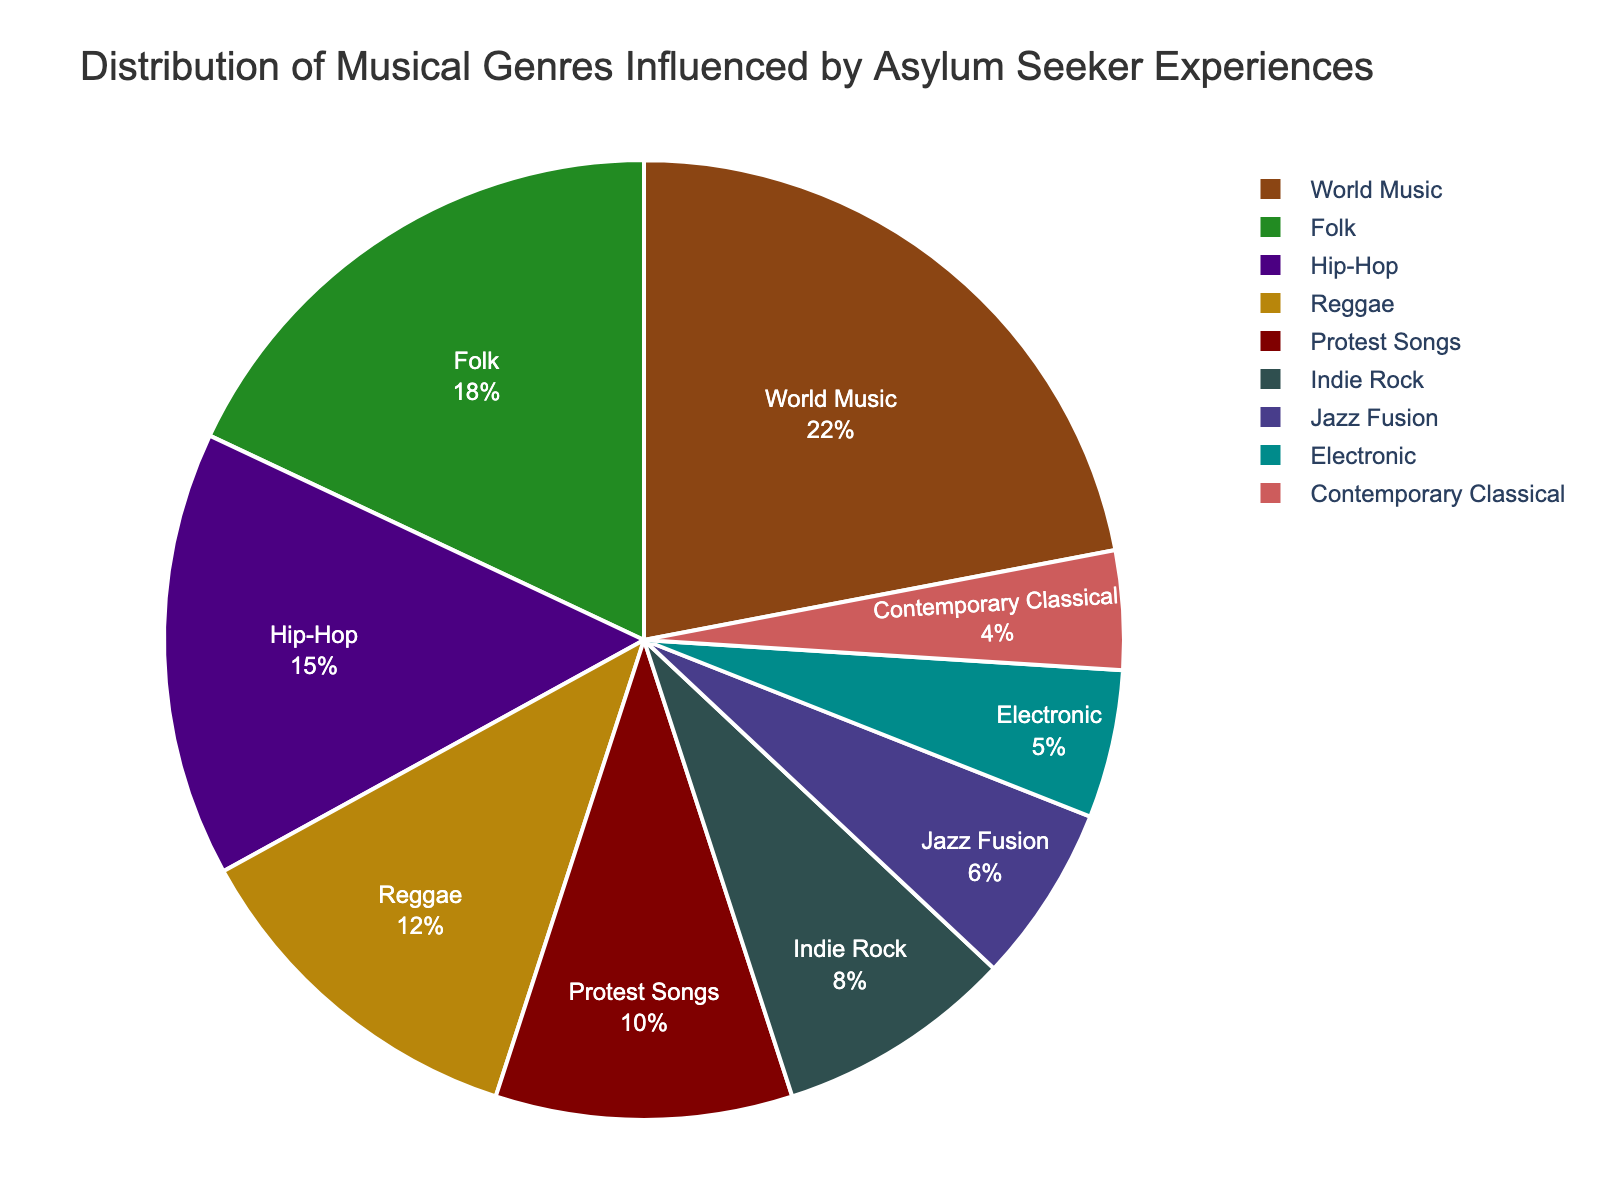What percentage of the pie chart is made up by World Music and Folk combined? To find the combined percentage of World Music and Folk, you need to sum their individual percentages: 22% for World Music and 18% for Folk. Thus, 22 + 18 equals 40%.
Answer: 40% Which genre has a higher percentage, Indie Rock or Jazz Fusion, and by how much? Indie Rock has 8%, and Jazz Fusion has 6%. To find out how much higher Indie Rock's percentage is, subtract Jazz Fusion's percentage from Indie Rock's: 8 - 6 equals 2%.
Answer: Indie Rock by 2% What proportion of the chart is represented by genres with a percentage of 10% or more? The genres with 10% or more are World Music (22%), Folk (18%), Hip-Hop (15%), and Reggae (12%). Adding these gives 22 + 18 + 15 + 12, which equals 67%.
Answer: 67% How does the size of the Protest Songs segment compare to the Contemporary Classical segment? Protest Songs have a percentage of 10%, while Contemporary Classical has 4%. Comparing them, Protest Songs are larger by 10 - 4%, which equals 6%.
Answer: Protest Songs by 6% If the percentage of Electronic music was doubled, what would the new total percentage be for Electronic? The current percentage for Electronic is 5%. Doubling this would mean multiplying 5 by 2, resulting in 10%.
Answer: 10% Is the percentage of Reggae greater than the sum of the percentages for Electronic and Contemporary Classical combined? Reggae is 12%. Electronic is 5%, and Contemporary Classical is 4%. The sum of Electronic and Contemporary Classical is 5 + 4, which equals 9%. Since 12% is greater than 9%, Reggae's percentage is greater.
Answer: Yes What are the three most represented genres in the pie chart? The genres with the highest percentages are World Music (22%), Folk (18%), and Hip-Hop (15%). These are the three most represented.
Answer: World Music, Folk, Hip-Hop What fraction of the pie chart is represented by Indie Rock and Jazz Fusion combined? Indie Rock represents 8%, and Jazz Fusion represents 6%. Combining these gives 8 + 6, which equals 14%. This 14% represents 14/100 or 7/50 as a fraction.
Answer: 7/50 Which genre segment appears in a darker color: Indie Rock or Electronic? Visually, Indie Rock is represented by a darker color compared to Electronic, based on the color palette used.
Answer: Indie Rock If Folk music's percentage increased by 4%, how would its new percentage compare to Hip-Hop's? Currently, Folk music is at 18%. Increasing this by 4% gives 18 + 4 = 22%. Hip-Hop is at 15%. Comparing these, 22% (new Folk) is greater than 15% (Hip-Hop).
Answer: Folk is greater by 7% 